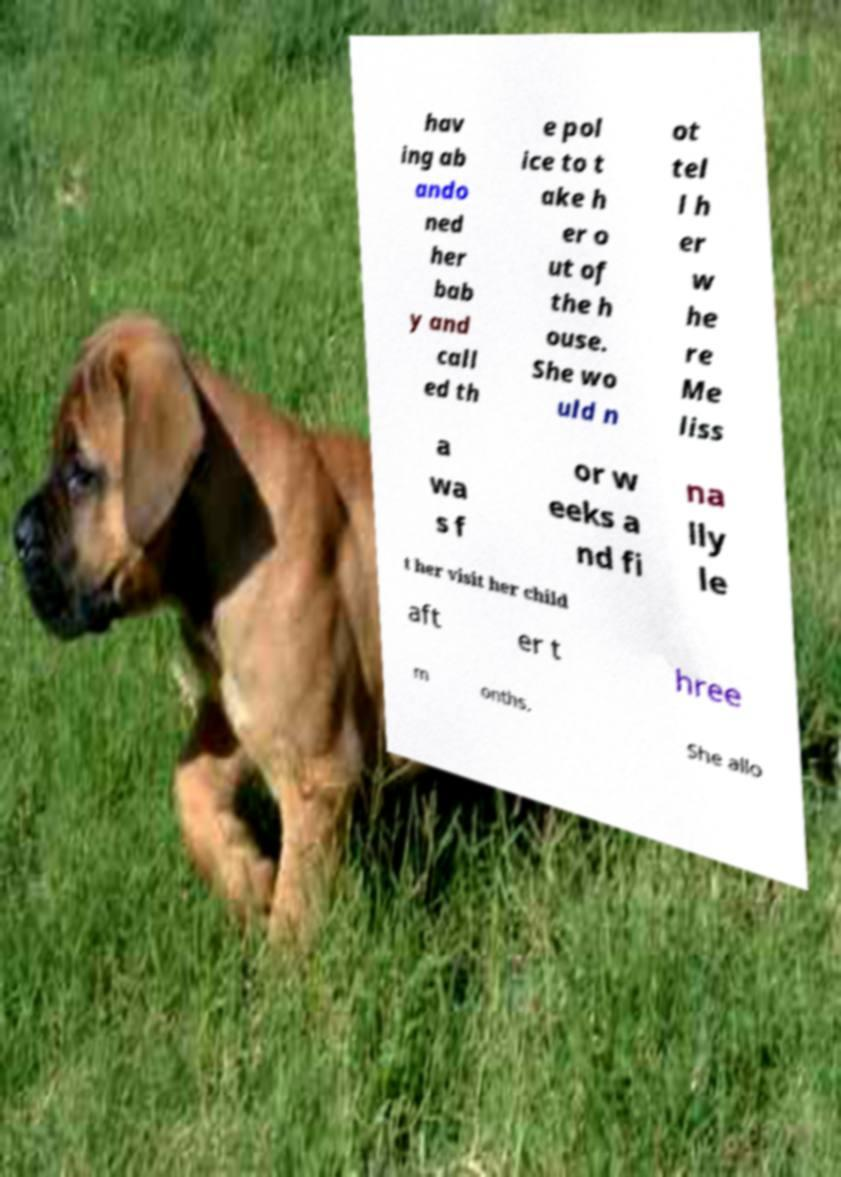Please read and relay the text visible in this image. What does it say? hav ing ab ando ned her bab y and call ed th e pol ice to t ake h er o ut of the h ouse. She wo uld n ot tel l h er w he re Me liss a wa s f or w eeks a nd fi na lly le t her visit her child aft er t hree m onths. She allo 